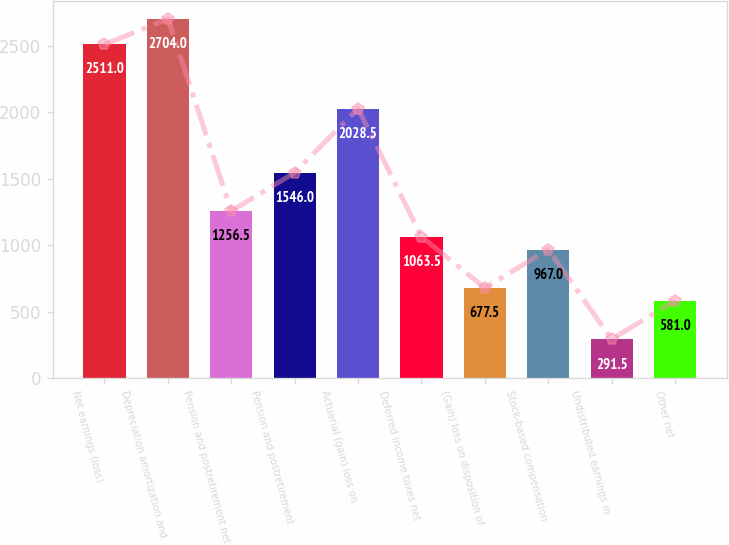Convert chart. <chart><loc_0><loc_0><loc_500><loc_500><bar_chart><fcel>Net earnings (loss)<fcel>Depreciation amortization and<fcel>Pension and postretirement net<fcel>Pension and postretirement<fcel>Actuarial (gain) loss on<fcel>Deferred income taxes net<fcel>(Gain) loss on disposition of<fcel>Stock-based compensation<fcel>Undistributed earnings in<fcel>Other net<nl><fcel>2511<fcel>2704<fcel>1256.5<fcel>1546<fcel>2028.5<fcel>1063.5<fcel>677.5<fcel>967<fcel>291.5<fcel>581<nl></chart> 